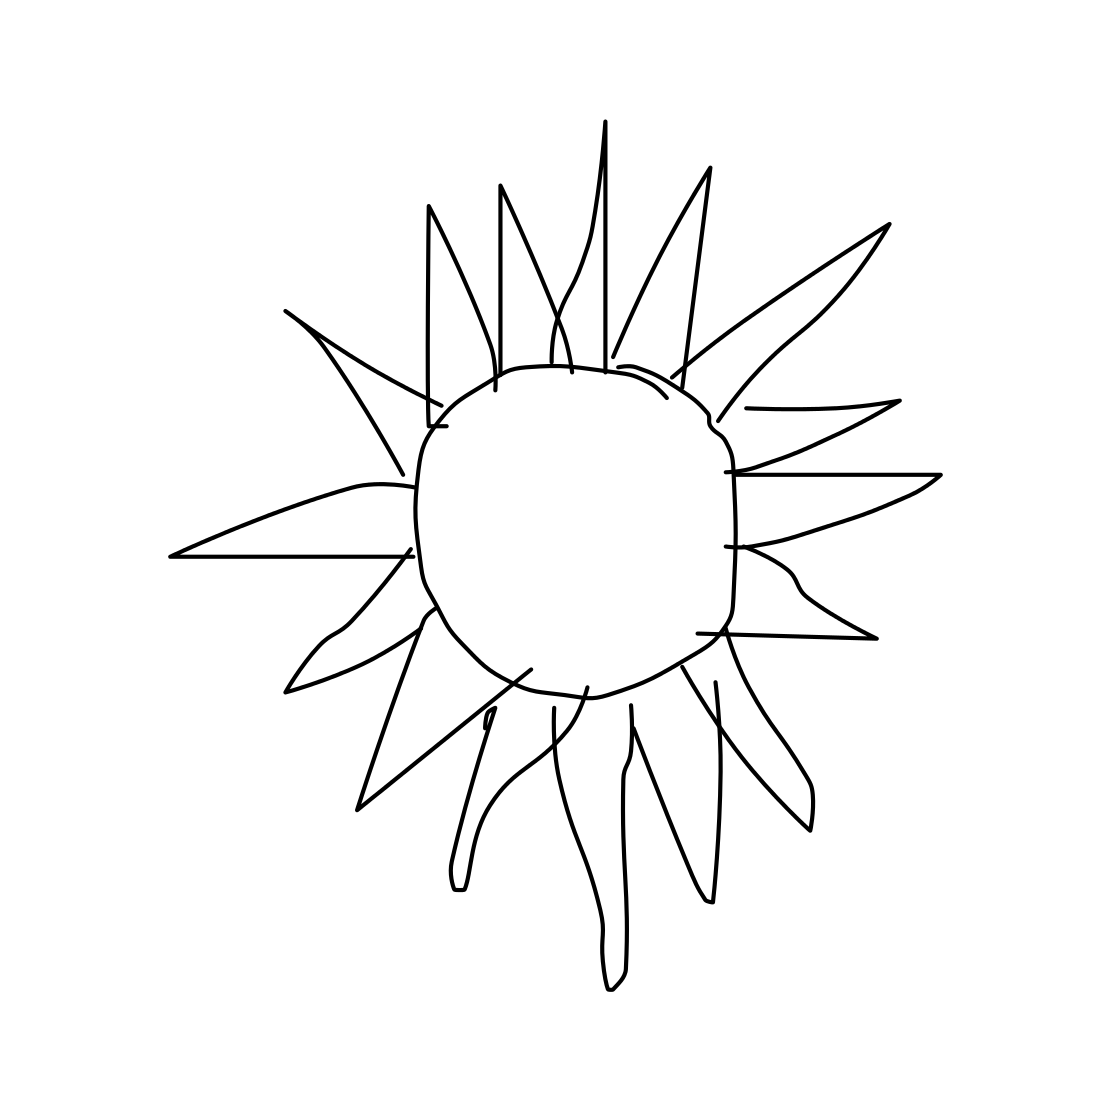Is this a guitar in the image? No, the image does not depict a guitar. It seems to be a simple line drawing of a sun with rays emanating from a central circle. 